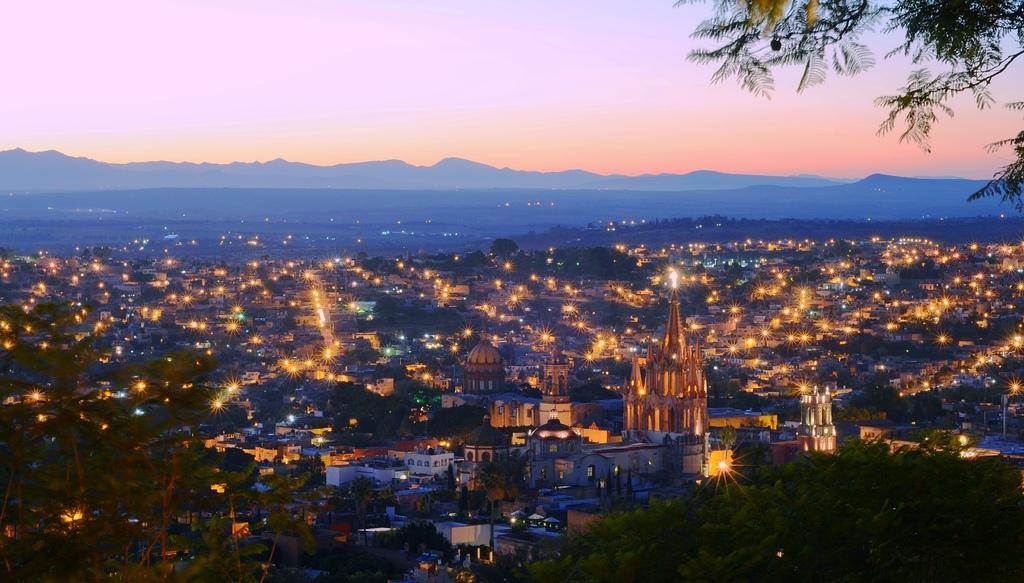Please provide a concise description of this image. In this picture we can see hills, buildings, lights, trees are there. At the top of the image we can see the sky. 